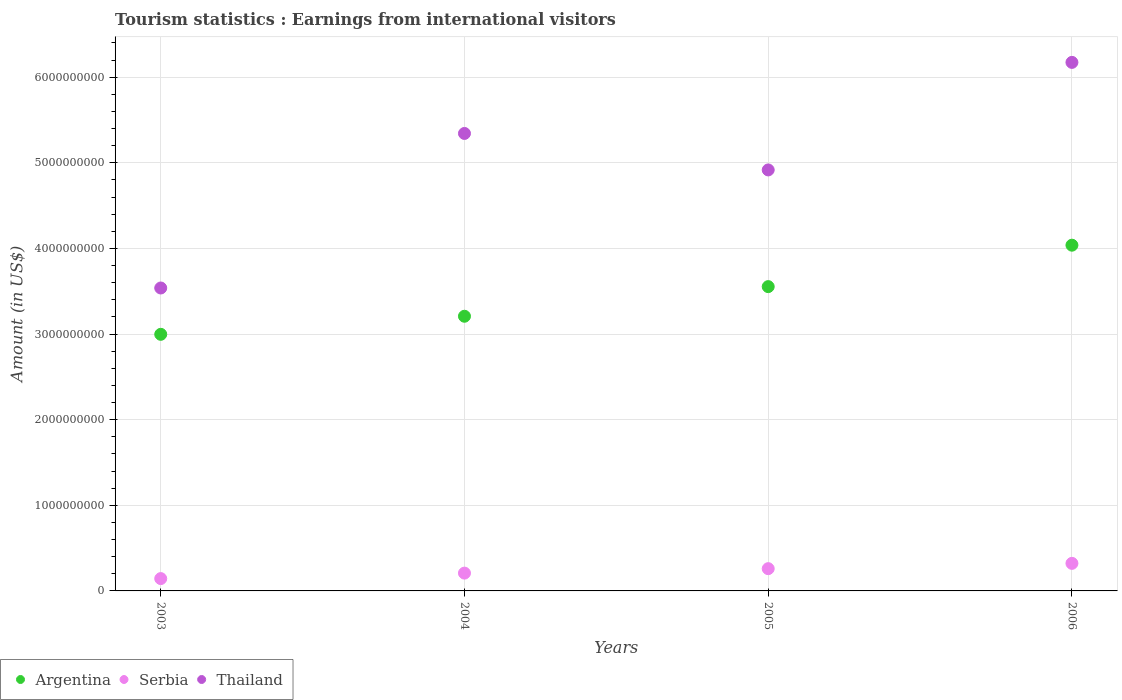What is the earnings from international visitors in Argentina in 2006?
Provide a short and direct response. 4.04e+09. Across all years, what is the maximum earnings from international visitors in Thailand?
Provide a short and direct response. 6.17e+09. Across all years, what is the minimum earnings from international visitors in Argentina?
Provide a succinct answer. 3.00e+09. In which year was the earnings from international visitors in Serbia maximum?
Provide a short and direct response. 2006. What is the total earnings from international visitors in Argentina in the graph?
Ensure brevity in your answer.  1.38e+1. What is the difference between the earnings from international visitors in Thailand in 2003 and that in 2004?
Make the answer very short. -1.80e+09. What is the difference between the earnings from international visitors in Argentina in 2006 and the earnings from international visitors in Serbia in 2004?
Offer a very short reply. 3.83e+09. What is the average earnings from international visitors in Thailand per year?
Make the answer very short. 4.99e+09. In the year 2004, what is the difference between the earnings from international visitors in Argentina and earnings from international visitors in Serbia?
Your answer should be very brief. 3.00e+09. In how many years, is the earnings from international visitors in Thailand greater than 4000000000 US$?
Ensure brevity in your answer.  3. What is the ratio of the earnings from international visitors in Argentina in 2003 to that in 2006?
Keep it short and to the point. 0.74. Is the earnings from international visitors in Serbia in 2003 less than that in 2004?
Keep it short and to the point. Yes. Is the difference between the earnings from international visitors in Argentina in 2004 and 2005 greater than the difference between the earnings from international visitors in Serbia in 2004 and 2005?
Provide a succinct answer. No. What is the difference between the highest and the second highest earnings from international visitors in Thailand?
Keep it short and to the point. 8.30e+08. What is the difference between the highest and the lowest earnings from international visitors in Serbia?
Your answer should be compact. 1.78e+08. In how many years, is the earnings from international visitors in Thailand greater than the average earnings from international visitors in Thailand taken over all years?
Provide a succinct answer. 2. Are the values on the major ticks of Y-axis written in scientific E-notation?
Keep it short and to the point. No. Does the graph contain grids?
Your answer should be compact. Yes. Where does the legend appear in the graph?
Keep it short and to the point. Bottom left. What is the title of the graph?
Provide a short and direct response. Tourism statistics : Earnings from international visitors. Does "Bahrain" appear as one of the legend labels in the graph?
Your response must be concise. No. What is the Amount (in US$) in Argentina in 2003?
Your response must be concise. 3.00e+09. What is the Amount (in US$) of Serbia in 2003?
Your response must be concise. 1.44e+08. What is the Amount (in US$) of Thailand in 2003?
Offer a terse response. 3.54e+09. What is the Amount (in US$) of Argentina in 2004?
Ensure brevity in your answer.  3.21e+09. What is the Amount (in US$) of Serbia in 2004?
Your response must be concise. 2.08e+08. What is the Amount (in US$) of Thailand in 2004?
Keep it short and to the point. 5.34e+09. What is the Amount (in US$) in Argentina in 2005?
Give a very brief answer. 3.55e+09. What is the Amount (in US$) of Serbia in 2005?
Offer a terse response. 2.60e+08. What is the Amount (in US$) of Thailand in 2005?
Ensure brevity in your answer.  4.92e+09. What is the Amount (in US$) in Argentina in 2006?
Your answer should be compact. 4.04e+09. What is the Amount (in US$) in Serbia in 2006?
Ensure brevity in your answer.  3.22e+08. What is the Amount (in US$) in Thailand in 2006?
Provide a short and direct response. 6.17e+09. Across all years, what is the maximum Amount (in US$) of Argentina?
Provide a short and direct response. 4.04e+09. Across all years, what is the maximum Amount (in US$) of Serbia?
Offer a terse response. 3.22e+08. Across all years, what is the maximum Amount (in US$) in Thailand?
Ensure brevity in your answer.  6.17e+09. Across all years, what is the minimum Amount (in US$) of Argentina?
Offer a terse response. 3.00e+09. Across all years, what is the minimum Amount (in US$) in Serbia?
Your answer should be very brief. 1.44e+08. Across all years, what is the minimum Amount (in US$) of Thailand?
Offer a very short reply. 3.54e+09. What is the total Amount (in US$) in Argentina in the graph?
Keep it short and to the point. 1.38e+1. What is the total Amount (in US$) of Serbia in the graph?
Your response must be concise. 9.34e+08. What is the total Amount (in US$) in Thailand in the graph?
Provide a short and direct response. 2.00e+1. What is the difference between the Amount (in US$) in Argentina in 2003 and that in 2004?
Give a very brief answer. -2.11e+08. What is the difference between the Amount (in US$) in Serbia in 2003 and that in 2004?
Your response must be concise. -6.40e+07. What is the difference between the Amount (in US$) of Thailand in 2003 and that in 2004?
Offer a terse response. -1.80e+09. What is the difference between the Amount (in US$) of Argentina in 2003 and that in 2005?
Offer a very short reply. -5.57e+08. What is the difference between the Amount (in US$) in Serbia in 2003 and that in 2005?
Your answer should be very brief. -1.16e+08. What is the difference between the Amount (in US$) of Thailand in 2003 and that in 2005?
Your response must be concise. -1.38e+09. What is the difference between the Amount (in US$) of Argentina in 2003 and that in 2006?
Provide a short and direct response. -1.04e+09. What is the difference between the Amount (in US$) in Serbia in 2003 and that in 2006?
Ensure brevity in your answer.  -1.78e+08. What is the difference between the Amount (in US$) in Thailand in 2003 and that in 2006?
Give a very brief answer. -2.64e+09. What is the difference between the Amount (in US$) in Argentina in 2004 and that in 2005?
Make the answer very short. -3.46e+08. What is the difference between the Amount (in US$) of Serbia in 2004 and that in 2005?
Offer a terse response. -5.20e+07. What is the difference between the Amount (in US$) of Thailand in 2004 and that in 2005?
Your answer should be very brief. 4.26e+08. What is the difference between the Amount (in US$) of Argentina in 2004 and that in 2006?
Ensure brevity in your answer.  -8.30e+08. What is the difference between the Amount (in US$) of Serbia in 2004 and that in 2006?
Provide a succinct answer. -1.14e+08. What is the difference between the Amount (in US$) in Thailand in 2004 and that in 2006?
Ensure brevity in your answer.  -8.30e+08. What is the difference between the Amount (in US$) in Argentina in 2005 and that in 2006?
Your answer should be very brief. -4.84e+08. What is the difference between the Amount (in US$) of Serbia in 2005 and that in 2006?
Offer a very short reply. -6.20e+07. What is the difference between the Amount (in US$) in Thailand in 2005 and that in 2006?
Offer a terse response. -1.26e+09. What is the difference between the Amount (in US$) of Argentina in 2003 and the Amount (in US$) of Serbia in 2004?
Your answer should be very brief. 2.79e+09. What is the difference between the Amount (in US$) of Argentina in 2003 and the Amount (in US$) of Thailand in 2004?
Ensure brevity in your answer.  -2.35e+09. What is the difference between the Amount (in US$) of Serbia in 2003 and the Amount (in US$) of Thailand in 2004?
Offer a very short reply. -5.20e+09. What is the difference between the Amount (in US$) in Argentina in 2003 and the Amount (in US$) in Serbia in 2005?
Give a very brief answer. 2.74e+09. What is the difference between the Amount (in US$) in Argentina in 2003 and the Amount (in US$) in Thailand in 2005?
Your answer should be very brief. -1.92e+09. What is the difference between the Amount (in US$) of Serbia in 2003 and the Amount (in US$) of Thailand in 2005?
Offer a very short reply. -4.77e+09. What is the difference between the Amount (in US$) in Argentina in 2003 and the Amount (in US$) in Serbia in 2006?
Ensure brevity in your answer.  2.68e+09. What is the difference between the Amount (in US$) in Argentina in 2003 and the Amount (in US$) in Thailand in 2006?
Offer a terse response. -3.18e+09. What is the difference between the Amount (in US$) of Serbia in 2003 and the Amount (in US$) of Thailand in 2006?
Your answer should be compact. -6.03e+09. What is the difference between the Amount (in US$) of Argentina in 2004 and the Amount (in US$) of Serbia in 2005?
Give a very brief answer. 2.95e+09. What is the difference between the Amount (in US$) in Argentina in 2004 and the Amount (in US$) in Thailand in 2005?
Provide a succinct answer. -1.71e+09. What is the difference between the Amount (in US$) in Serbia in 2004 and the Amount (in US$) in Thailand in 2005?
Provide a short and direct response. -4.71e+09. What is the difference between the Amount (in US$) in Argentina in 2004 and the Amount (in US$) in Serbia in 2006?
Give a very brief answer. 2.89e+09. What is the difference between the Amount (in US$) of Argentina in 2004 and the Amount (in US$) of Thailand in 2006?
Make the answer very short. -2.96e+09. What is the difference between the Amount (in US$) of Serbia in 2004 and the Amount (in US$) of Thailand in 2006?
Offer a very short reply. -5.96e+09. What is the difference between the Amount (in US$) of Argentina in 2005 and the Amount (in US$) of Serbia in 2006?
Ensure brevity in your answer.  3.23e+09. What is the difference between the Amount (in US$) in Argentina in 2005 and the Amount (in US$) in Thailand in 2006?
Keep it short and to the point. -2.62e+09. What is the difference between the Amount (in US$) in Serbia in 2005 and the Amount (in US$) in Thailand in 2006?
Your response must be concise. -5.91e+09. What is the average Amount (in US$) in Argentina per year?
Keep it short and to the point. 3.45e+09. What is the average Amount (in US$) of Serbia per year?
Offer a terse response. 2.34e+08. What is the average Amount (in US$) of Thailand per year?
Provide a succinct answer. 4.99e+09. In the year 2003, what is the difference between the Amount (in US$) in Argentina and Amount (in US$) in Serbia?
Ensure brevity in your answer.  2.85e+09. In the year 2003, what is the difference between the Amount (in US$) of Argentina and Amount (in US$) of Thailand?
Your answer should be very brief. -5.41e+08. In the year 2003, what is the difference between the Amount (in US$) in Serbia and Amount (in US$) in Thailand?
Ensure brevity in your answer.  -3.39e+09. In the year 2004, what is the difference between the Amount (in US$) of Argentina and Amount (in US$) of Serbia?
Your answer should be very brief. 3.00e+09. In the year 2004, what is the difference between the Amount (in US$) of Argentina and Amount (in US$) of Thailand?
Give a very brief answer. -2.14e+09. In the year 2004, what is the difference between the Amount (in US$) in Serbia and Amount (in US$) in Thailand?
Your answer should be compact. -5.14e+09. In the year 2005, what is the difference between the Amount (in US$) in Argentina and Amount (in US$) in Serbia?
Give a very brief answer. 3.29e+09. In the year 2005, what is the difference between the Amount (in US$) in Argentina and Amount (in US$) in Thailand?
Your answer should be very brief. -1.36e+09. In the year 2005, what is the difference between the Amount (in US$) in Serbia and Amount (in US$) in Thailand?
Provide a short and direct response. -4.66e+09. In the year 2006, what is the difference between the Amount (in US$) in Argentina and Amount (in US$) in Serbia?
Offer a very short reply. 3.72e+09. In the year 2006, what is the difference between the Amount (in US$) in Argentina and Amount (in US$) in Thailand?
Keep it short and to the point. -2.14e+09. In the year 2006, what is the difference between the Amount (in US$) of Serbia and Amount (in US$) of Thailand?
Offer a terse response. -5.85e+09. What is the ratio of the Amount (in US$) in Argentina in 2003 to that in 2004?
Make the answer very short. 0.93. What is the ratio of the Amount (in US$) of Serbia in 2003 to that in 2004?
Offer a very short reply. 0.69. What is the ratio of the Amount (in US$) in Thailand in 2003 to that in 2004?
Ensure brevity in your answer.  0.66. What is the ratio of the Amount (in US$) in Argentina in 2003 to that in 2005?
Your answer should be compact. 0.84. What is the ratio of the Amount (in US$) in Serbia in 2003 to that in 2005?
Provide a short and direct response. 0.55. What is the ratio of the Amount (in US$) in Thailand in 2003 to that in 2005?
Provide a short and direct response. 0.72. What is the ratio of the Amount (in US$) in Argentina in 2003 to that in 2006?
Provide a succinct answer. 0.74. What is the ratio of the Amount (in US$) of Serbia in 2003 to that in 2006?
Offer a very short reply. 0.45. What is the ratio of the Amount (in US$) of Thailand in 2003 to that in 2006?
Ensure brevity in your answer.  0.57. What is the ratio of the Amount (in US$) in Argentina in 2004 to that in 2005?
Offer a very short reply. 0.9. What is the ratio of the Amount (in US$) in Serbia in 2004 to that in 2005?
Offer a terse response. 0.8. What is the ratio of the Amount (in US$) in Thailand in 2004 to that in 2005?
Offer a terse response. 1.09. What is the ratio of the Amount (in US$) of Argentina in 2004 to that in 2006?
Your response must be concise. 0.79. What is the ratio of the Amount (in US$) of Serbia in 2004 to that in 2006?
Make the answer very short. 0.65. What is the ratio of the Amount (in US$) in Thailand in 2004 to that in 2006?
Make the answer very short. 0.87. What is the ratio of the Amount (in US$) of Argentina in 2005 to that in 2006?
Offer a terse response. 0.88. What is the ratio of the Amount (in US$) of Serbia in 2005 to that in 2006?
Give a very brief answer. 0.81. What is the ratio of the Amount (in US$) in Thailand in 2005 to that in 2006?
Give a very brief answer. 0.8. What is the difference between the highest and the second highest Amount (in US$) of Argentina?
Keep it short and to the point. 4.84e+08. What is the difference between the highest and the second highest Amount (in US$) of Serbia?
Your response must be concise. 6.20e+07. What is the difference between the highest and the second highest Amount (in US$) in Thailand?
Provide a short and direct response. 8.30e+08. What is the difference between the highest and the lowest Amount (in US$) in Argentina?
Provide a succinct answer. 1.04e+09. What is the difference between the highest and the lowest Amount (in US$) in Serbia?
Offer a terse response. 1.78e+08. What is the difference between the highest and the lowest Amount (in US$) in Thailand?
Provide a short and direct response. 2.64e+09. 